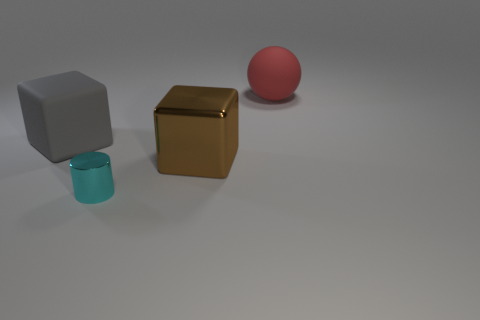Add 1 big red metallic cylinders. How many big red metallic cylinders exist? 1 Add 3 big gray objects. How many objects exist? 7 Subtract all gray cubes. How many cubes are left? 1 Subtract 0 yellow blocks. How many objects are left? 4 Subtract all cylinders. How many objects are left? 3 Subtract 1 spheres. How many spheres are left? 0 Subtract all purple cylinders. Subtract all blue blocks. How many cylinders are left? 1 Subtract all blue cylinders. How many gray cubes are left? 1 Subtract all green cylinders. Subtract all tiny shiny cylinders. How many objects are left? 3 Add 1 red objects. How many red objects are left? 2 